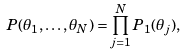Convert formula to latex. <formula><loc_0><loc_0><loc_500><loc_500>P ( \theta _ { 1 } , \dots , \theta _ { N } ) = \prod _ { j = 1 } ^ { N } P _ { 1 } ( \theta _ { j } ) ,</formula> 